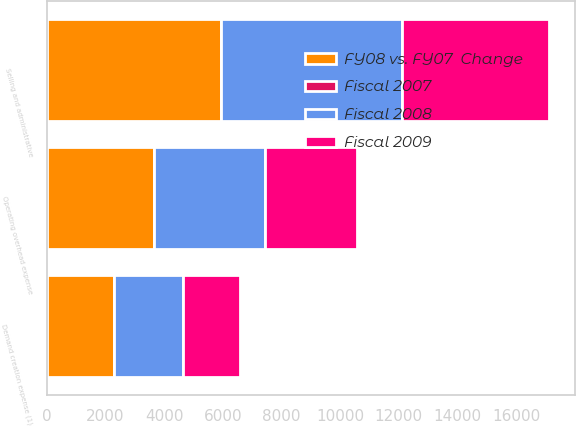Convert chart to OTSL. <chart><loc_0><loc_0><loc_500><loc_500><stacked_bar_chart><ecel><fcel>Operating overhead expense<fcel>Demand creation expense (1)<fcel>Selling and administrative<nl><fcel>Fiscal 2008<fcel>3798.2<fcel>2351.4<fcel>6149.6<nl><fcel>FY08 vs. FY07  Change<fcel>3645.4<fcel>2308.3<fcel>5953.7<nl><fcel>Fiscal 2007<fcel>4<fcel>2<fcel>3<nl><fcel>Fiscal 2009<fcel>3116.3<fcel>1912.4<fcel>5028.7<nl></chart> 